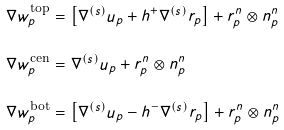<formula> <loc_0><loc_0><loc_500><loc_500>\nabla w _ { p } ^ { \text {top} } & = \left [ \nabla ^ { ( s ) } u _ { p } + h ^ { + } \nabla ^ { ( s ) } r _ { p } \right ] + r _ { p } ^ { n } \otimes n _ { p } ^ { n } \\ \nabla w _ { p } ^ { \text {cen} } & = \nabla ^ { ( s ) } u _ { p } + r _ { p } ^ { n } \otimes n _ { p } ^ { n } \\ \nabla w _ { p } ^ { \text {bot} } & = \left [ \nabla ^ { ( s ) } u _ { p } - h ^ { - } \nabla ^ { ( s ) } r _ { p } \right ] + r _ { p } ^ { n } \otimes n _ { p } ^ { n }</formula> 